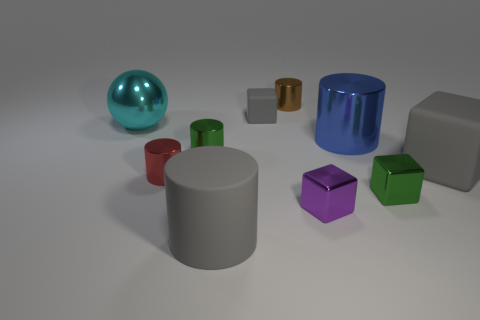Subtract all small brown cylinders. How many cylinders are left? 4 Subtract all red cylinders. How many cylinders are left? 4 Subtract all blue cylinders. Subtract all purple balls. How many cylinders are left? 4 Subtract all cubes. How many objects are left? 6 Subtract all yellow matte cubes. Subtract all brown cylinders. How many objects are left? 9 Add 3 tiny rubber blocks. How many tiny rubber blocks are left? 4 Add 2 large gray things. How many large gray things exist? 4 Subtract 0 purple cylinders. How many objects are left? 10 